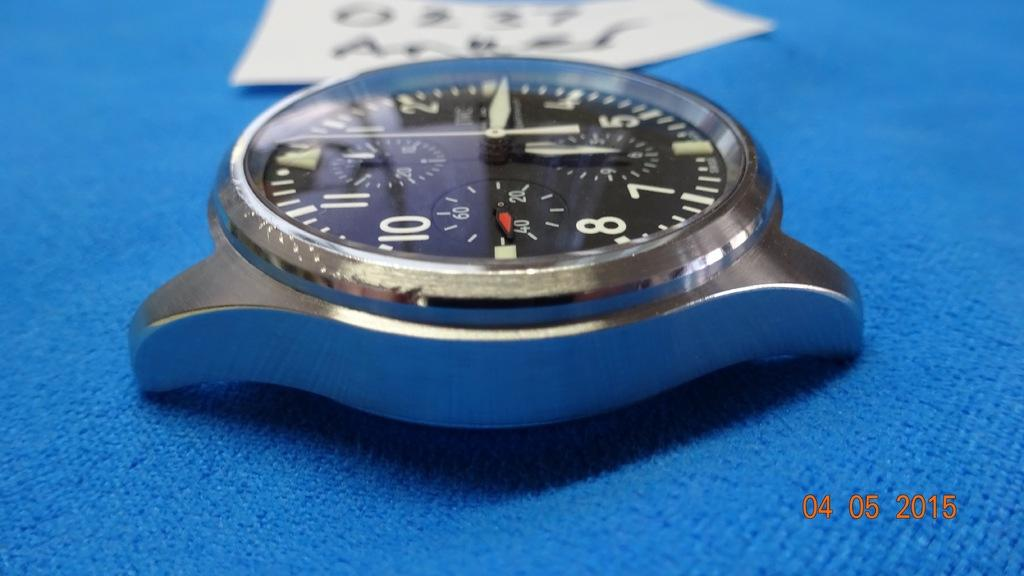<image>
Create a compact narrative representing the image presented. A wristwatch separated from its band is seen in an image dated 04 05 2015. 